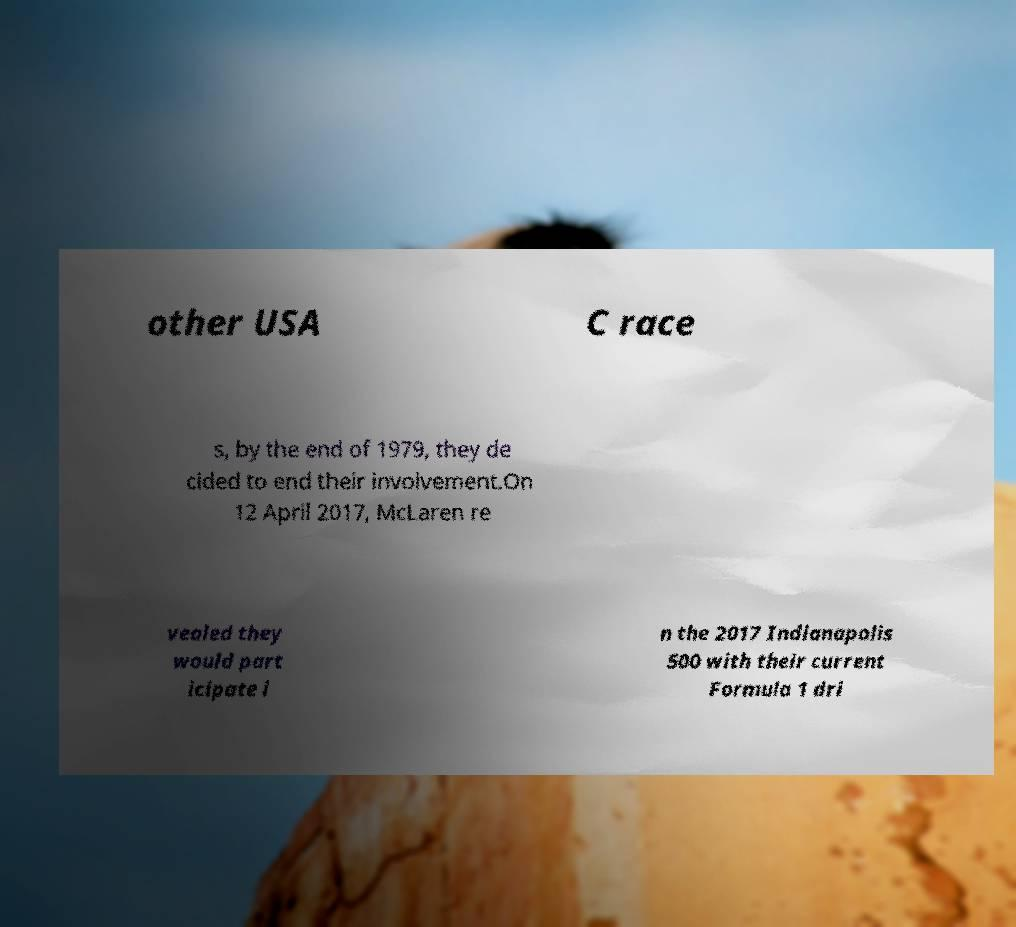I need the written content from this picture converted into text. Can you do that? other USA C race s, by the end of 1979, they de cided to end their involvement.On 12 April 2017, McLaren re vealed they would part icipate i n the 2017 Indianapolis 500 with their current Formula 1 dri 